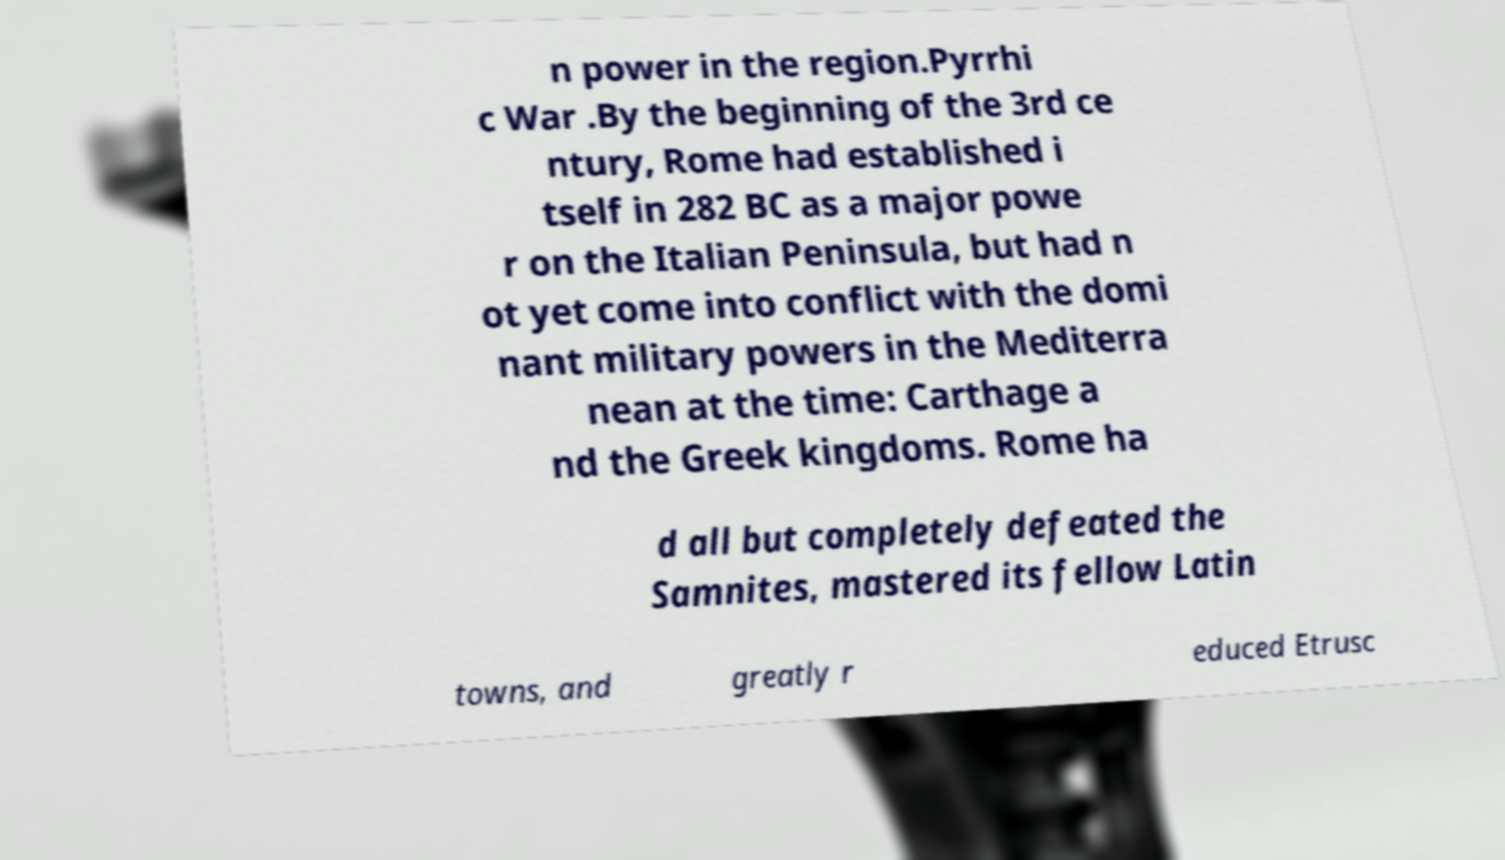What messages or text are displayed in this image? I need them in a readable, typed format. n power in the region.Pyrrhi c War .By the beginning of the 3rd ce ntury, Rome had established i tself in 282 BC as a major powe r on the Italian Peninsula, but had n ot yet come into conflict with the domi nant military powers in the Mediterra nean at the time: Carthage a nd the Greek kingdoms. Rome ha d all but completely defeated the Samnites, mastered its fellow Latin towns, and greatly r educed Etrusc 